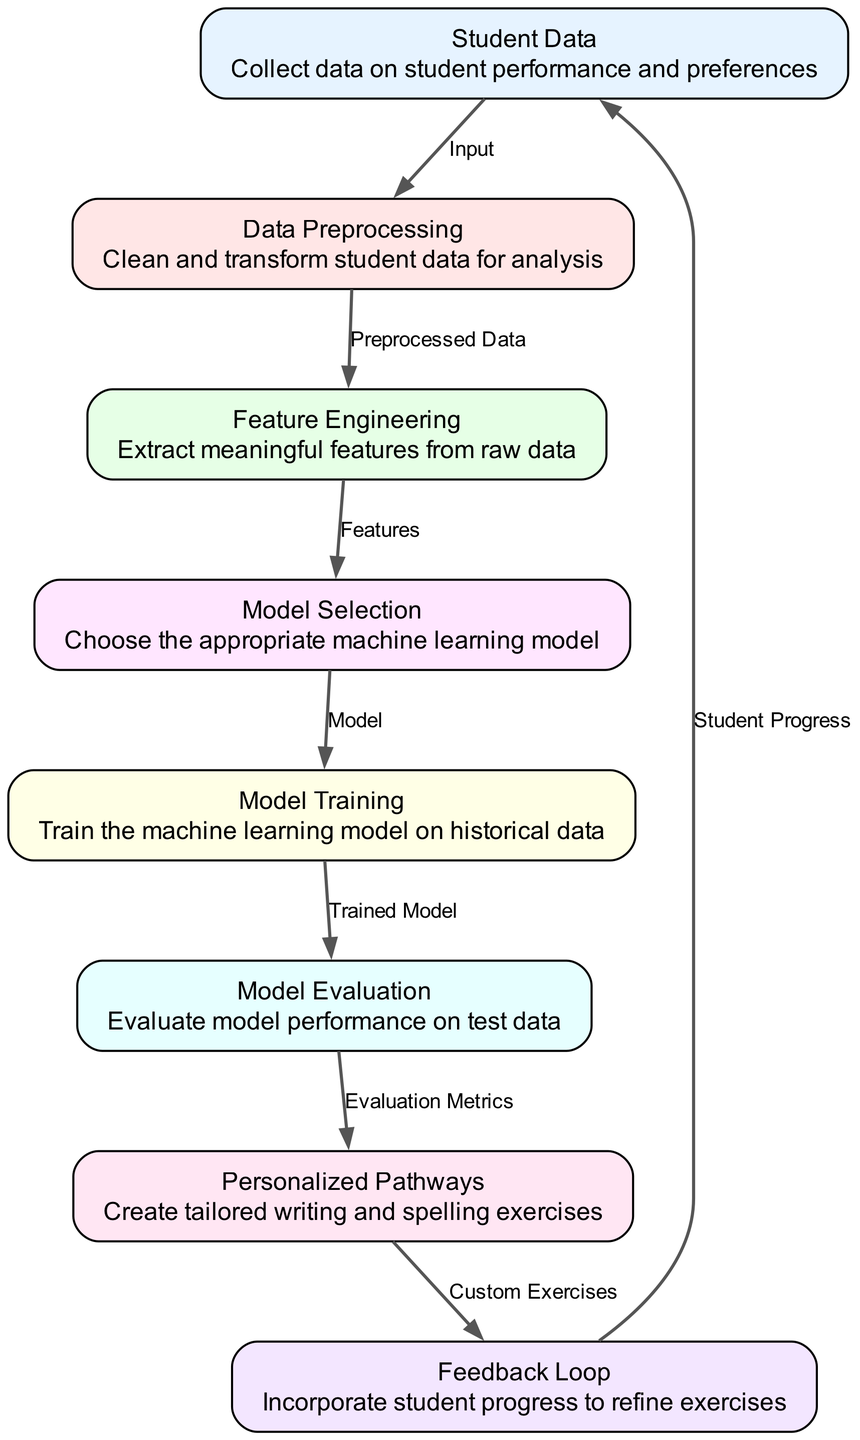What is the first node in the diagram? The first node in the diagram is "Student Data," which represents the collection of data on student performance and preferences.
Answer: Student Data How many nodes are present in the diagram? There are a total of eight nodes present in the diagram, each representing different stages of the machine learning process.
Answer: Eight What type of data is fed into the data preprocessing node? The data fed into the data preprocessing node is "Student Data," which is collected prior to cleaning and transforming for analysis.
Answer: Student Data Which node is responsible for evaluating the performance of the machine learning model? The node responsible for evaluating the performance of the machine learning model is "Model Evaluation," where metrics are assessed to determine model effectiveness.
Answer: Model Evaluation What is the output of the model training node? The output of the model training node is the "Trained Model," which indicates that the machine learning model has been fitted with historical data.
Answer: Trained Model What process occurs after model selection and before personalized pathways? After model selection, the next process that occurs is model training, where the chosen machine learning model is trained on historical data.
Answer: Model Training How does the feedback loop interact with the student data? The feedback loop interacts with the student data by incorporating "Student Progress" to refine the personalized exercises tailored for each student.
Answer: Student Progress Which node connects personalized pathways with feedback loop? The node that connects personalized pathways with feedback loop is "Personalized Pathways," where custom exercises are created based on evaluation metrics.
Answer: Personalized Pathways What is the role of feature engineering in this diagram? The role of feature engineering is to extract meaningful features from raw student data, which are essential for the subsequent model selection process.
Answer: Extract meaningful features 